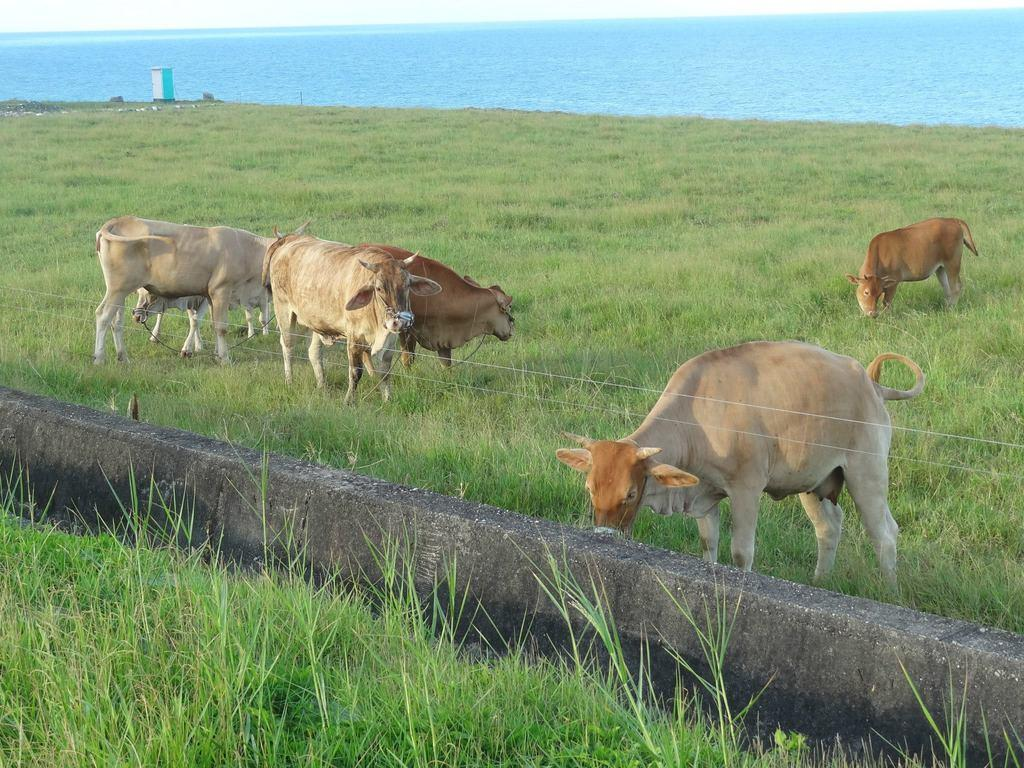What type of animals are in the image? There are cows in the image. What is the cows standing on in the image? There is grass in the image. What structure can be seen in the image? There is a wall in the image. What can be seen in the distance in the image? There is water visible in the background of the image. What type of humor can be seen in the image? There is no humor present in the image; it features cows, grass, a wall, and water in the background. 